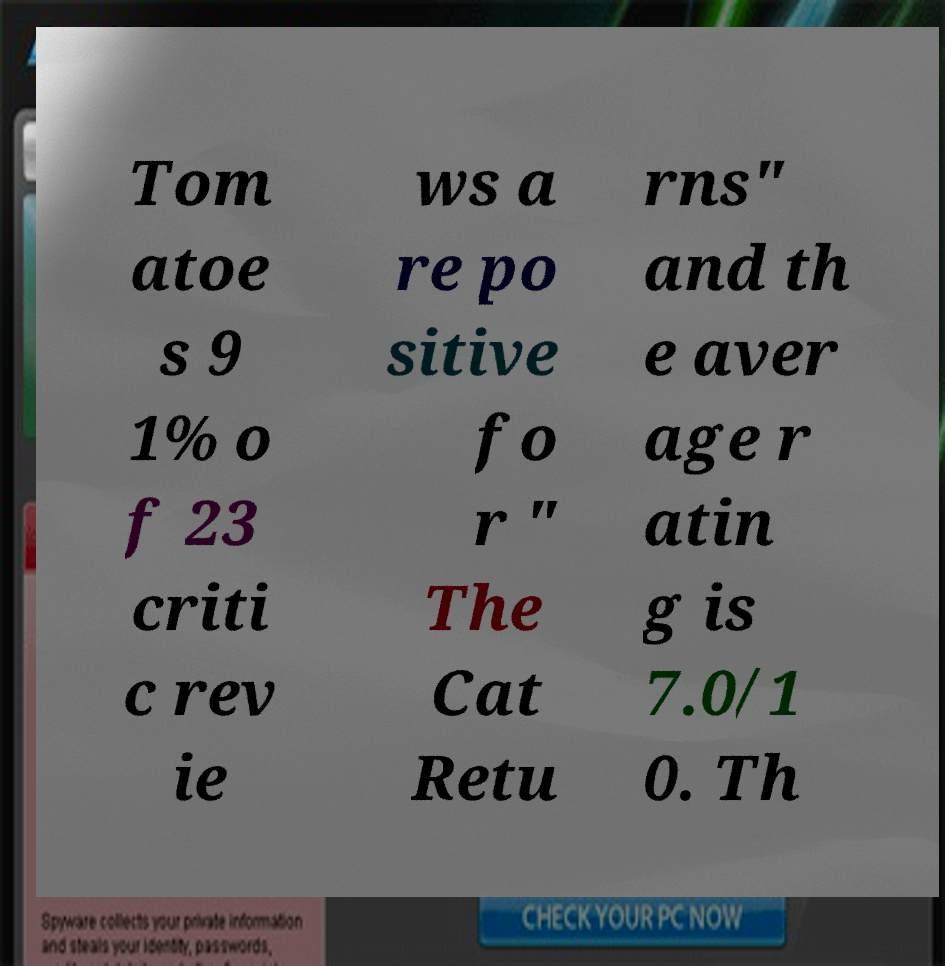For documentation purposes, I need the text within this image transcribed. Could you provide that? Tom atoe s 9 1% o f 23 criti c rev ie ws a re po sitive fo r " The Cat Retu rns" and th e aver age r atin g is 7.0/1 0. Th 